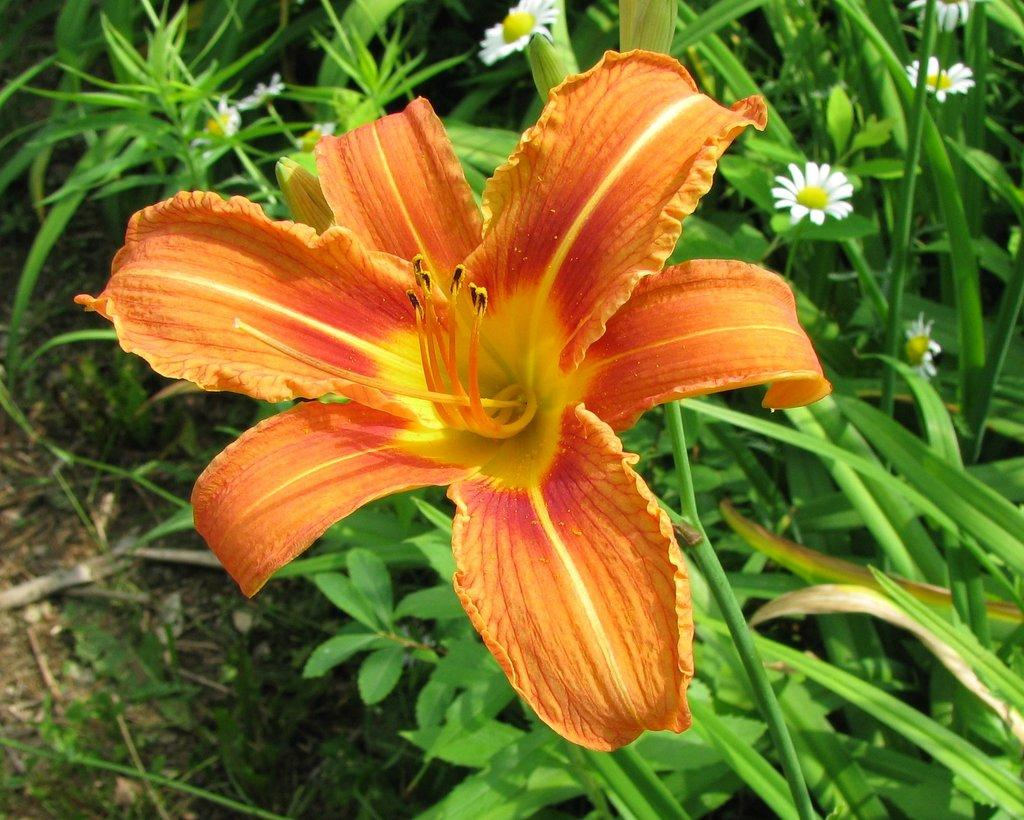What type of plants can be seen in the image? There are flower plants in the image. Can you describe the appearance of the flower plants? The flower plants have colorful blooms and green leaves. Are there any other objects or elements in the image besides the flower plants? The provided facts do not mention any other objects or elements in the image. What type of insect can be seen crawling on the cub in the image? There is no cub or insect present in the image; it only features flower plants. 